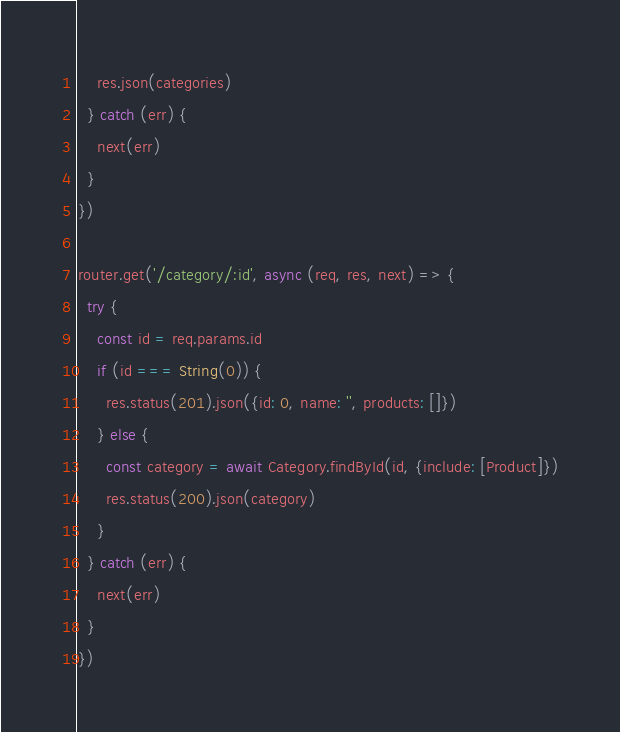<code> <loc_0><loc_0><loc_500><loc_500><_JavaScript_>    res.json(categories)
  } catch (err) {
    next(err)
  }
})

router.get('/category/:id', async (req, res, next) => {
  try {
    const id = req.params.id
    if (id === String(0)) {
      res.status(201).json({id: 0, name: '', products: []})
    } else {
      const category = await Category.findById(id, {include: [Product]})
      res.status(200).json(category)
    }
  } catch (err) {
    next(err)
  }
})
</code> 